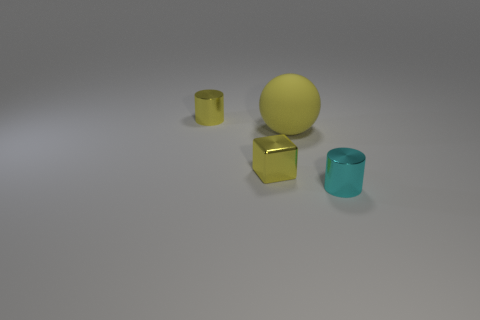Does the matte object have the same color as the shiny thing that is behind the tiny block?
Provide a succinct answer. Yes. Is there a ball that has the same material as the cyan cylinder?
Provide a succinct answer. No. How many tiny shiny cylinders are there?
Make the answer very short. 2. What is the material of the small yellow object that is right of the yellow thing that is behind the big yellow object?
Provide a short and direct response. Metal. What is the color of the tiny cylinder that is made of the same material as the tiny cyan thing?
Provide a succinct answer. Yellow. The large object that is the same color as the tiny metallic block is what shape?
Your answer should be very brief. Sphere. Does the yellow object on the right side of the tiny yellow block have the same size as the metal cylinder right of the tiny yellow metal cylinder?
Offer a terse response. No. How many spheres are either tiny objects or small yellow things?
Ensure brevity in your answer.  0. Are the cylinder on the right side of the big sphere and the big yellow object made of the same material?
Provide a succinct answer. No. What number of other objects are there of the same size as the cyan thing?
Keep it short and to the point. 2. 